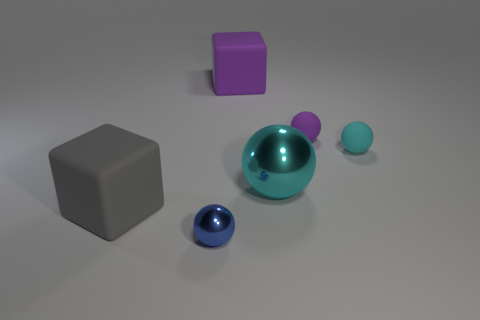Subtract all small cyan rubber balls. How many balls are left? 3 Subtract all purple cylinders. How many cyan balls are left? 2 Subtract all blue balls. How many balls are left? 3 Subtract 2 balls. How many balls are left? 2 Add 1 small brown spheres. How many objects exist? 7 Subtract all brown balls. Subtract all blue cylinders. How many balls are left? 4 Subtract all balls. How many objects are left? 2 Subtract all large purple matte cubes. Subtract all large objects. How many objects are left? 2 Add 2 tiny blue spheres. How many tiny blue spheres are left? 3 Add 1 cyan metallic objects. How many cyan metallic objects exist? 2 